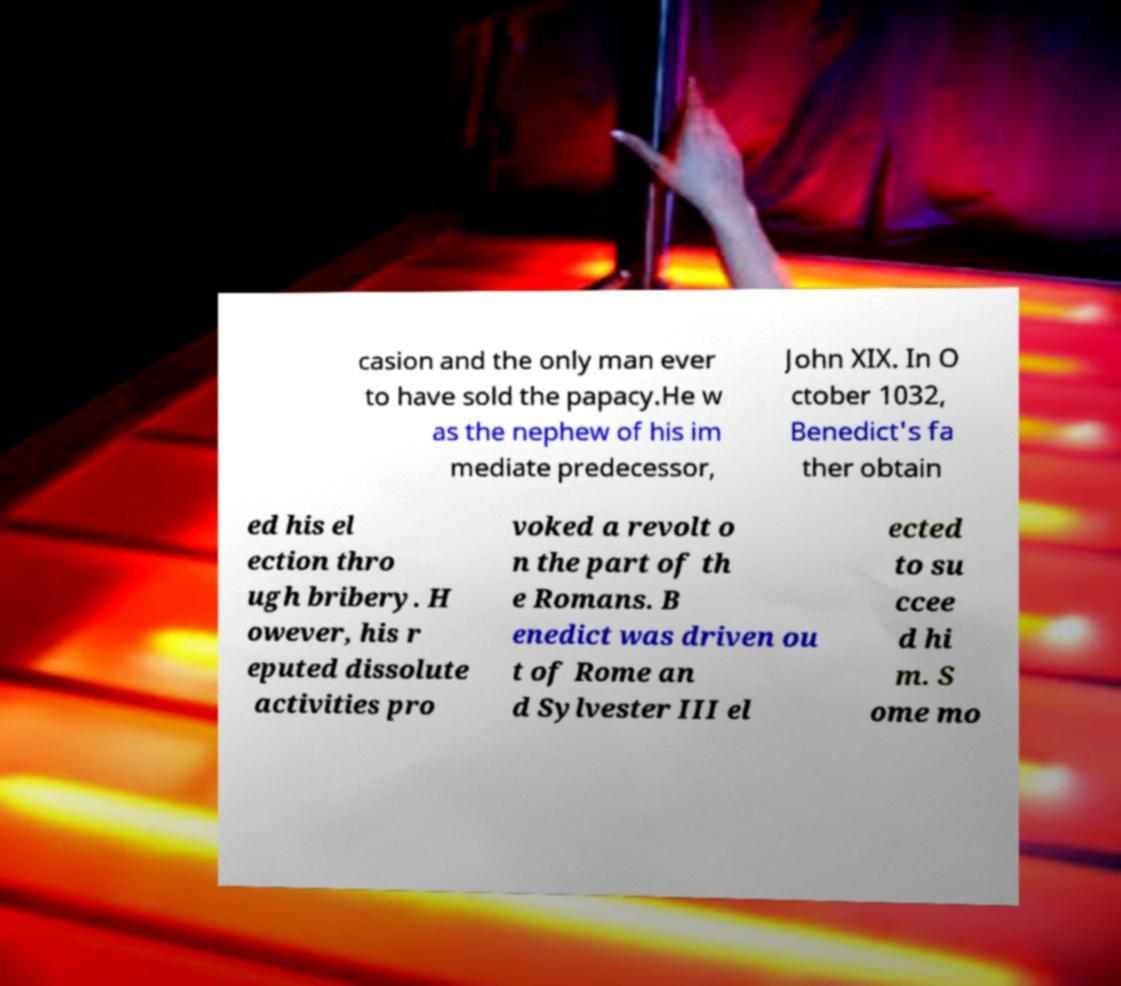Can you accurately transcribe the text from the provided image for me? casion and the only man ever to have sold the papacy.He w as the nephew of his im mediate predecessor, John XIX. In O ctober 1032, Benedict's fa ther obtain ed his el ection thro ugh bribery. H owever, his r eputed dissolute activities pro voked a revolt o n the part of th e Romans. B enedict was driven ou t of Rome an d Sylvester III el ected to su ccee d hi m. S ome mo 